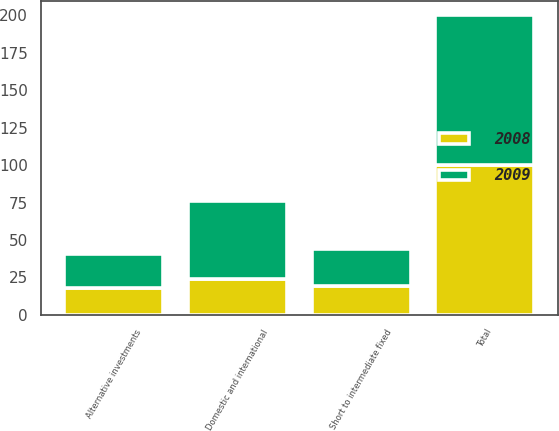<chart> <loc_0><loc_0><loc_500><loc_500><stacked_bar_chart><ecel><fcel>Domestic and international<fcel>Short to intermediate fixed<fcel>Alternative investments<fcel>Total<nl><fcel>2008<fcel>24<fcel>19<fcel>18<fcel>100<nl><fcel>2009<fcel>52<fcel>25<fcel>23<fcel>100<nl></chart> 